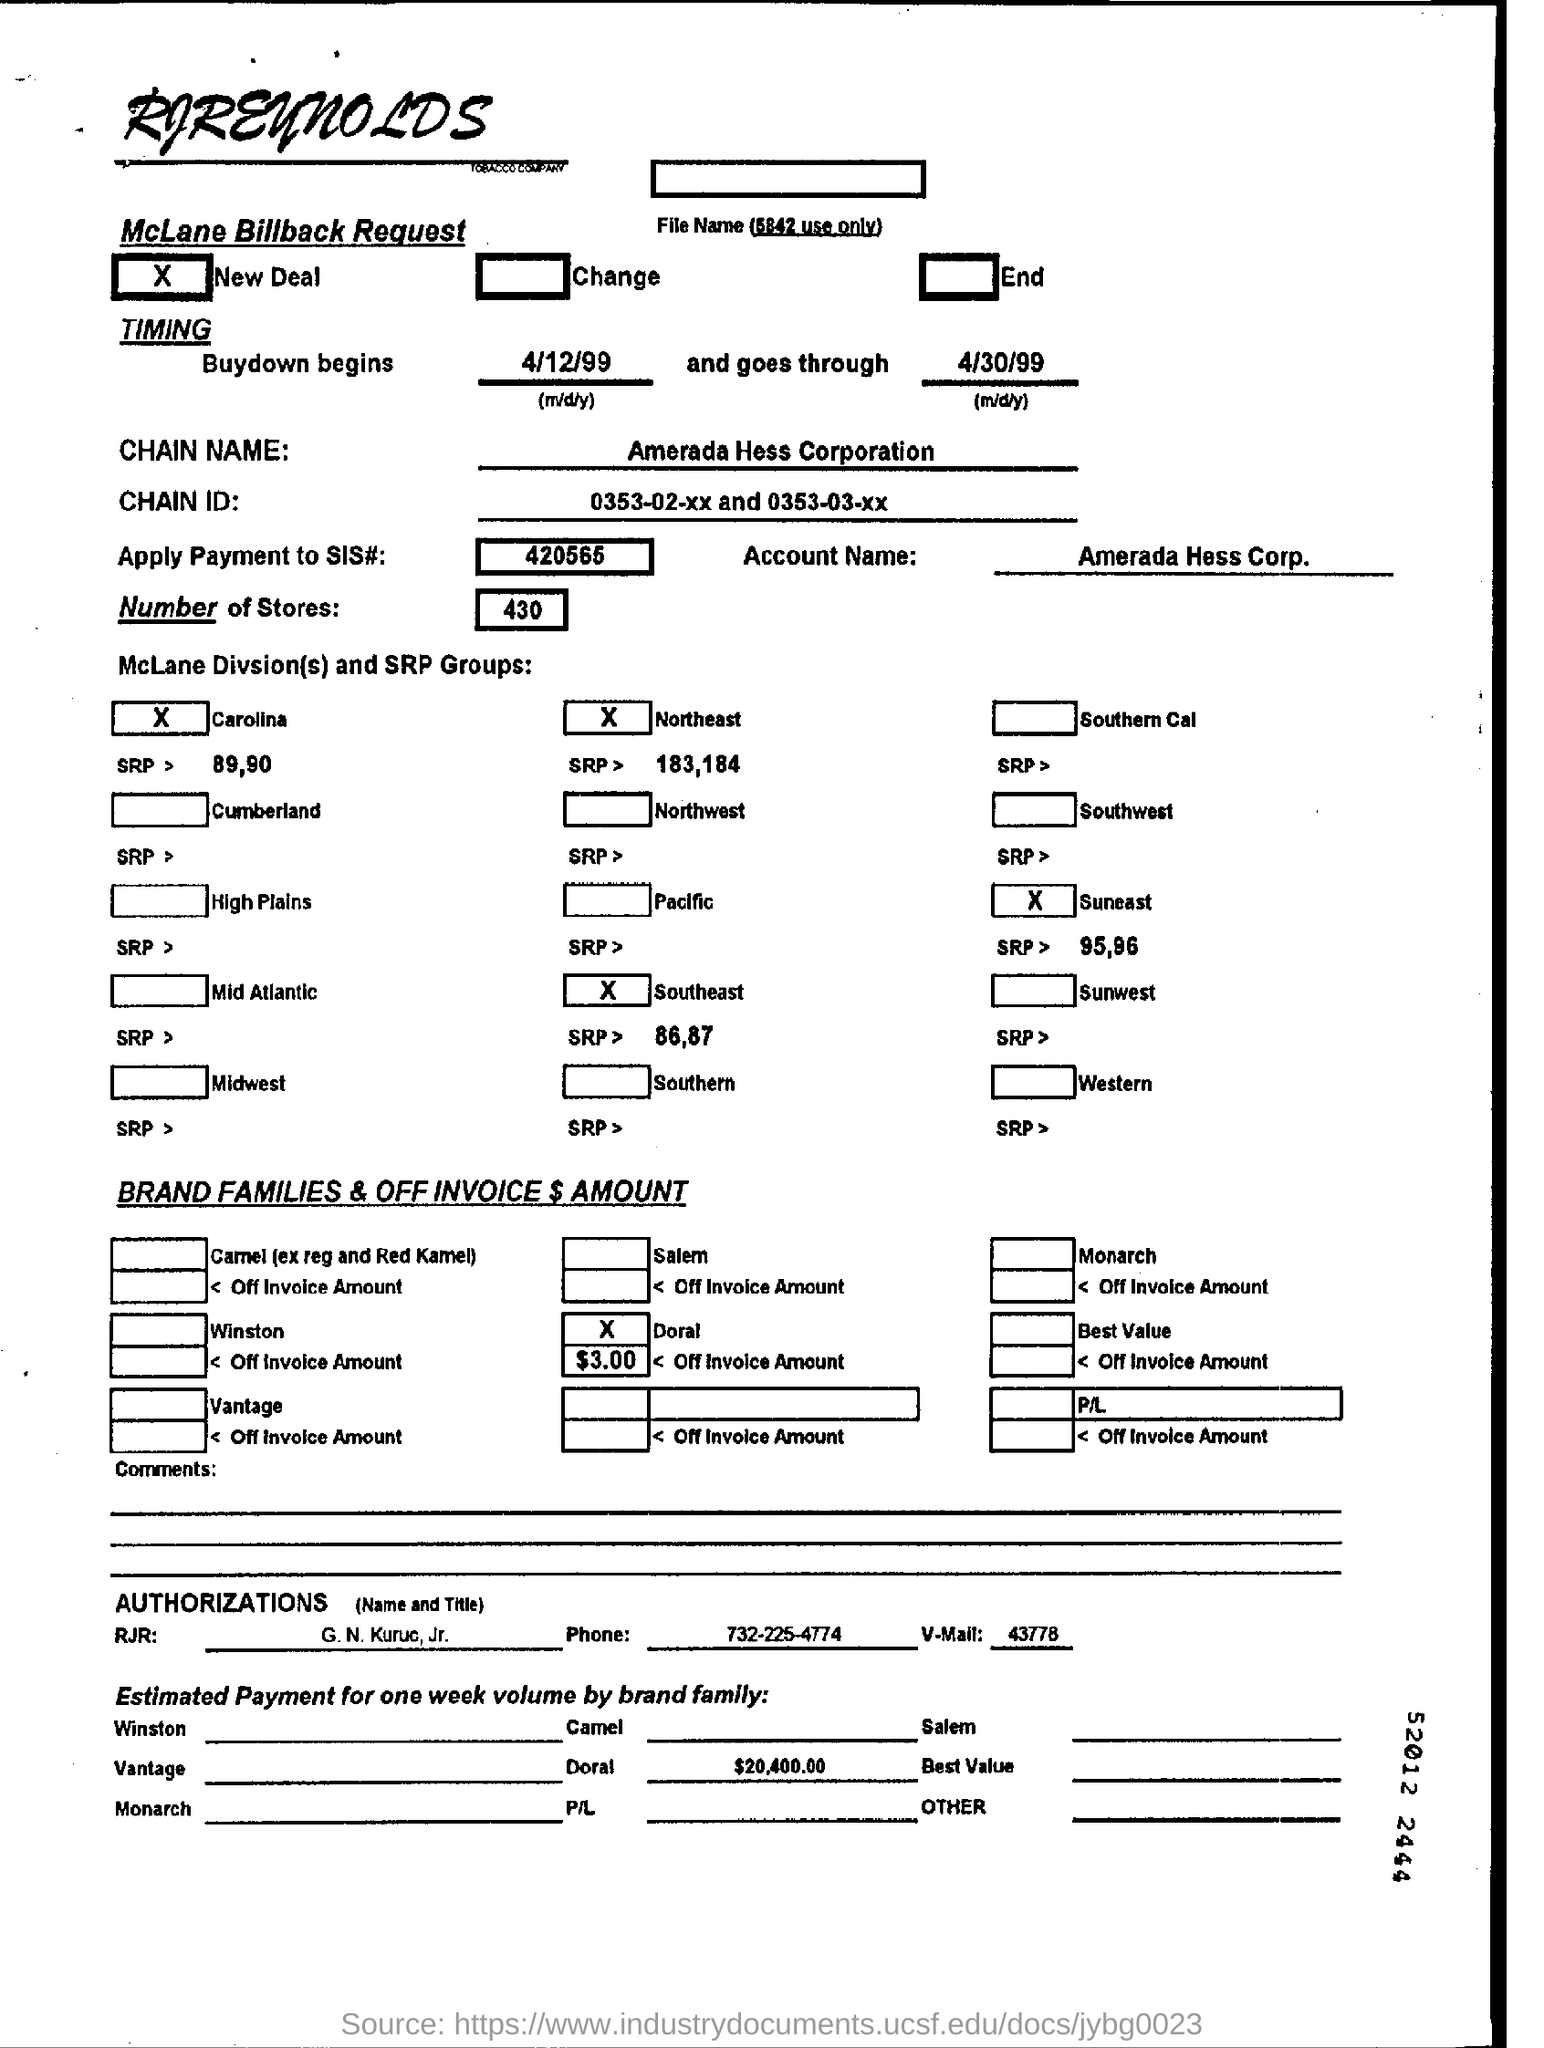Draw attention to some important aspects in this diagram. The estimated payment for one week's volume by Doral Family is approximately 20,400.00. In the McLane billback request form, there are 430 stores mentioned. The chain name mentioned on the form is Amerada Hess Corporation. 